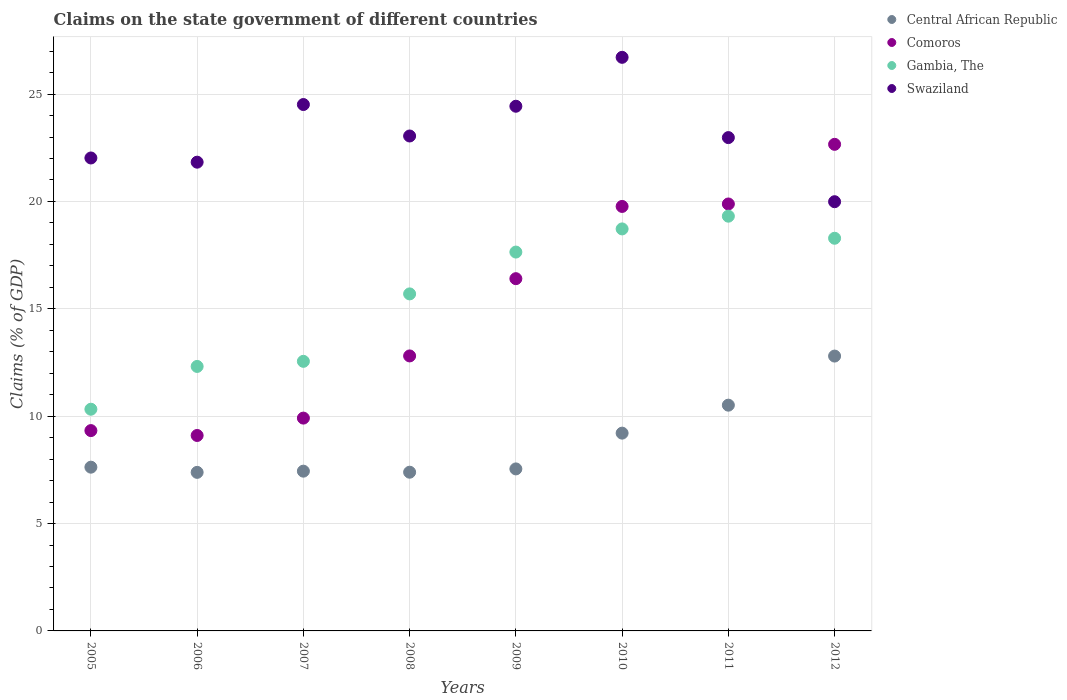How many different coloured dotlines are there?
Make the answer very short. 4. Is the number of dotlines equal to the number of legend labels?
Your answer should be very brief. Yes. What is the percentage of GDP claimed on the state government in Central African Republic in 2010?
Your answer should be compact. 9.21. Across all years, what is the maximum percentage of GDP claimed on the state government in Swaziland?
Keep it short and to the point. 26.71. Across all years, what is the minimum percentage of GDP claimed on the state government in Gambia, The?
Ensure brevity in your answer.  10.32. In which year was the percentage of GDP claimed on the state government in Comoros minimum?
Offer a terse response. 2006. What is the total percentage of GDP claimed on the state government in Central African Republic in the graph?
Offer a very short reply. 69.91. What is the difference between the percentage of GDP claimed on the state government in Comoros in 2005 and that in 2012?
Your answer should be very brief. -13.33. What is the difference between the percentage of GDP claimed on the state government in Swaziland in 2006 and the percentage of GDP claimed on the state government in Central African Republic in 2010?
Your answer should be very brief. 12.62. What is the average percentage of GDP claimed on the state government in Gambia, The per year?
Offer a terse response. 15.61. In the year 2006, what is the difference between the percentage of GDP claimed on the state government in Swaziland and percentage of GDP claimed on the state government in Comoros?
Keep it short and to the point. 12.73. In how many years, is the percentage of GDP claimed on the state government in Gambia, The greater than 8 %?
Make the answer very short. 8. What is the ratio of the percentage of GDP claimed on the state government in Comoros in 2006 to that in 2011?
Keep it short and to the point. 0.46. Is the percentage of GDP claimed on the state government in Comoros in 2010 less than that in 2012?
Offer a terse response. Yes. Is the difference between the percentage of GDP claimed on the state government in Swaziland in 2008 and 2010 greater than the difference between the percentage of GDP claimed on the state government in Comoros in 2008 and 2010?
Provide a succinct answer. Yes. What is the difference between the highest and the second highest percentage of GDP claimed on the state government in Gambia, The?
Offer a terse response. 0.59. What is the difference between the highest and the lowest percentage of GDP claimed on the state government in Gambia, The?
Give a very brief answer. 8.99. Is it the case that in every year, the sum of the percentage of GDP claimed on the state government in Central African Republic and percentage of GDP claimed on the state government in Gambia, The  is greater than the sum of percentage of GDP claimed on the state government in Comoros and percentage of GDP claimed on the state government in Swaziland?
Keep it short and to the point. No. Does the percentage of GDP claimed on the state government in Comoros monotonically increase over the years?
Ensure brevity in your answer.  No. How many dotlines are there?
Give a very brief answer. 4. How many years are there in the graph?
Your answer should be compact. 8. What is the difference between two consecutive major ticks on the Y-axis?
Ensure brevity in your answer.  5. Are the values on the major ticks of Y-axis written in scientific E-notation?
Provide a succinct answer. No. Does the graph contain any zero values?
Offer a terse response. No. What is the title of the graph?
Offer a very short reply. Claims on the state government of different countries. What is the label or title of the X-axis?
Ensure brevity in your answer.  Years. What is the label or title of the Y-axis?
Your answer should be very brief. Claims (% of GDP). What is the Claims (% of GDP) in Central African Republic in 2005?
Keep it short and to the point. 7.63. What is the Claims (% of GDP) of Comoros in 2005?
Make the answer very short. 9.33. What is the Claims (% of GDP) in Gambia, The in 2005?
Keep it short and to the point. 10.32. What is the Claims (% of GDP) of Swaziland in 2005?
Keep it short and to the point. 22.03. What is the Claims (% of GDP) in Central African Republic in 2006?
Provide a succinct answer. 7.38. What is the Claims (% of GDP) of Comoros in 2006?
Provide a succinct answer. 9.1. What is the Claims (% of GDP) in Gambia, The in 2006?
Give a very brief answer. 12.32. What is the Claims (% of GDP) in Swaziland in 2006?
Provide a short and direct response. 21.83. What is the Claims (% of GDP) of Central African Republic in 2007?
Your answer should be compact. 7.44. What is the Claims (% of GDP) in Comoros in 2007?
Ensure brevity in your answer.  9.91. What is the Claims (% of GDP) of Gambia, The in 2007?
Offer a very short reply. 12.55. What is the Claims (% of GDP) of Swaziland in 2007?
Make the answer very short. 24.51. What is the Claims (% of GDP) of Central African Republic in 2008?
Provide a succinct answer. 7.39. What is the Claims (% of GDP) of Comoros in 2008?
Your answer should be compact. 12.81. What is the Claims (% of GDP) of Gambia, The in 2008?
Make the answer very short. 15.7. What is the Claims (% of GDP) in Swaziland in 2008?
Keep it short and to the point. 23.05. What is the Claims (% of GDP) of Central African Republic in 2009?
Give a very brief answer. 7.54. What is the Claims (% of GDP) of Comoros in 2009?
Keep it short and to the point. 16.4. What is the Claims (% of GDP) in Gambia, The in 2009?
Provide a succinct answer. 17.64. What is the Claims (% of GDP) in Swaziland in 2009?
Your answer should be compact. 24.43. What is the Claims (% of GDP) of Central African Republic in 2010?
Your answer should be very brief. 9.21. What is the Claims (% of GDP) in Comoros in 2010?
Keep it short and to the point. 19.77. What is the Claims (% of GDP) in Gambia, The in 2010?
Provide a succinct answer. 18.72. What is the Claims (% of GDP) in Swaziland in 2010?
Make the answer very short. 26.71. What is the Claims (% of GDP) in Central African Republic in 2011?
Your response must be concise. 10.51. What is the Claims (% of GDP) of Comoros in 2011?
Your answer should be compact. 19.88. What is the Claims (% of GDP) of Gambia, The in 2011?
Offer a terse response. 19.31. What is the Claims (% of GDP) of Swaziland in 2011?
Your response must be concise. 22.97. What is the Claims (% of GDP) in Central African Republic in 2012?
Offer a terse response. 12.8. What is the Claims (% of GDP) of Comoros in 2012?
Ensure brevity in your answer.  22.66. What is the Claims (% of GDP) in Gambia, The in 2012?
Ensure brevity in your answer.  18.29. What is the Claims (% of GDP) of Swaziland in 2012?
Provide a succinct answer. 19.99. Across all years, what is the maximum Claims (% of GDP) of Central African Republic?
Make the answer very short. 12.8. Across all years, what is the maximum Claims (% of GDP) of Comoros?
Offer a very short reply. 22.66. Across all years, what is the maximum Claims (% of GDP) in Gambia, The?
Your response must be concise. 19.31. Across all years, what is the maximum Claims (% of GDP) in Swaziland?
Ensure brevity in your answer.  26.71. Across all years, what is the minimum Claims (% of GDP) of Central African Republic?
Your response must be concise. 7.38. Across all years, what is the minimum Claims (% of GDP) of Comoros?
Provide a short and direct response. 9.1. Across all years, what is the minimum Claims (% of GDP) in Gambia, The?
Offer a very short reply. 10.32. Across all years, what is the minimum Claims (% of GDP) in Swaziland?
Give a very brief answer. 19.99. What is the total Claims (% of GDP) of Central African Republic in the graph?
Provide a succinct answer. 69.91. What is the total Claims (% of GDP) in Comoros in the graph?
Keep it short and to the point. 119.86. What is the total Claims (% of GDP) of Gambia, The in the graph?
Provide a succinct answer. 124.86. What is the total Claims (% of GDP) of Swaziland in the graph?
Offer a terse response. 185.53. What is the difference between the Claims (% of GDP) in Central African Republic in 2005 and that in 2006?
Ensure brevity in your answer.  0.24. What is the difference between the Claims (% of GDP) of Comoros in 2005 and that in 2006?
Keep it short and to the point. 0.23. What is the difference between the Claims (% of GDP) in Gambia, The in 2005 and that in 2006?
Make the answer very short. -1.99. What is the difference between the Claims (% of GDP) of Swaziland in 2005 and that in 2006?
Give a very brief answer. 0.2. What is the difference between the Claims (% of GDP) in Central African Republic in 2005 and that in 2007?
Your answer should be very brief. 0.19. What is the difference between the Claims (% of GDP) of Comoros in 2005 and that in 2007?
Provide a succinct answer. -0.58. What is the difference between the Claims (% of GDP) in Gambia, The in 2005 and that in 2007?
Offer a terse response. -2.23. What is the difference between the Claims (% of GDP) in Swaziland in 2005 and that in 2007?
Offer a terse response. -2.49. What is the difference between the Claims (% of GDP) in Central African Republic in 2005 and that in 2008?
Offer a terse response. 0.23. What is the difference between the Claims (% of GDP) of Comoros in 2005 and that in 2008?
Offer a terse response. -3.48. What is the difference between the Claims (% of GDP) of Gambia, The in 2005 and that in 2008?
Ensure brevity in your answer.  -5.37. What is the difference between the Claims (% of GDP) in Swaziland in 2005 and that in 2008?
Offer a terse response. -1.02. What is the difference between the Claims (% of GDP) in Central African Republic in 2005 and that in 2009?
Your response must be concise. 0.08. What is the difference between the Claims (% of GDP) of Comoros in 2005 and that in 2009?
Give a very brief answer. -7.08. What is the difference between the Claims (% of GDP) of Gambia, The in 2005 and that in 2009?
Your answer should be compact. -7.32. What is the difference between the Claims (% of GDP) in Swaziland in 2005 and that in 2009?
Ensure brevity in your answer.  -2.41. What is the difference between the Claims (% of GDP) of Central African Republic in 2005 and that in 2010?
Offer a very short reply. -1.59. What is the difference between the Claims (% of GDP) of Comoros in 2005 and that in 2010?
Provide a short and direct response. -10.44. What is the difference between the Claims (% of GDP) of Gambia, The in 2005 and that in 2010?
Your response must be concise. -8.4. What is the difference between the Claims (% of GDP) in Swaziland in 2005 and that in 2010?
Offer a very short reply. -4.69. What is the difference between the Claims (% of GDP) of Central African Republic in 2005 and that in 2011?
Your answer should be compact. -2.89. What is the difference between the Claims (% of GDP) in Comoros in 2005 and that in 2011?
Offer a very short reply. -10.55. What is the difference between the Claims (% of GDP) in Gambia, The in 2005 and that in 2011?
Your response must be concise. -8.99. What is the difference between the Claims (% of GDP) in Swaziland in 2005 and that in 2011?
Give a very brief answer. -0.95. What is the difference between the Claims (% of GDP) in Central African Republic in 2005 and that in 2012?
Provide a succinct answer. -5.17. What is the difference between the Claims (% of GDP) of Comoros in 2005 and that in 2012?
Ensure brevity in your answer.  -13.33. What is the difference between the Claims (% of GDP) in Gambia, The in 2005 and that in 2012?
Make the answer very short. -7.96. What is the difference between the Claims (% of GDP) in Swaziland in 2005 and that in 2012?
Ensure brevity in your answer.  2.04. What is the difference between the Claims (% of GDP) in Central African Republic in 2006 and that in 2007?
Offer a very short reply. -0.06. What is the difference between the Claims (% of GDP) in Comoros in 2006 and that in 2007?
Keep it short and to the point. -0.81. What is the difference between the Claims (% of GDP) in Gambia, The in 2006 and that in 2007?
Provide a succinct answer. -0.24. What is the difference between the Claims (% of GDP) in Swaziland in 2006 and that in 2007?
Make the answer very short. -2.68. What is the difference between the Claims (% of GDP) in Central African Republic in 2006 and that in 2008?
Give a very brief answer. -0.01. What is the difference between the Claims (% of GDP) in Comoros in 2006 and that in 2008?
Make the answer very short. -3.7. What is the difference between the Claims (% of GDP) in Gambia, The in 2006 and that in 2008?
Give a very brief answer. -3.38. What is the difference between the Claims (% of GDP) of Swaziland in 2006 and that in 2008?
Offer a terse response. -1.22. What is the difference between the Claims (% of GDP) in Central African Republic in 2006 and that in 2009?
Provide a short and direct response. -0.16. What is the difference between the Claims (% of GDP) of Comoros in 2006 and that in 2009?
Provide a short and direct response. -7.3. What is the difference between the Claims (% of GDP) in Gambia, The in 2006 and that in 2009?
Your response must be concise. -5.33. What is the difference between the Claims (% of GDP) in Swaziland in 2006 and that in 2009?
Provide a short and direct response. -2.6. What is the difference between the Claims (% of GDP) in Central African Republic in 2006 and that in 2010?
Your response must be concise. -1.83. What is the difference between the Claims (% of GDP) in Comoros in 2006 and that in 2010?
Your answer should be compact. -10.67. What is the difference between the Claims (% of GDP) of Gambia, The in 2006 and that in 2010?
Offer a very short reply. -6.4. What is the difference between the Claims (% of GDP) of Swaziland in 2006 and that in 2010?
Make the answer very short. -4.88. What is the difference between the Claims (% of GDP) of Central African Republic in 2006 and that in 2011?
Offer a very short reply. -3.13. What is the difference between the Claims (% of GDP) in Comoros in 2006 and that in 2011?
Keep it short and to the point. -10.78. What is the difference between the Claims (% of GDP) in Gambia, The in 2006 and that in 2011?
Provide a succinct answer. -7. What is the difference between the Claims (% of GDP) in Swaziland in 2006 and that in 2011?
Your response must be concise. -1.14. What is the difference between the Claims (% of GDP) of Central African Republic in 2006 and that in 2012?
Keep it short and to the point. -5.42. What is the difference between the Claims (% of GDP) in Comoros in 2006 and that in 2012?
Provide a succinct answer. -13.56. What is the difference between the Claims (% of GDP) in Gambia, The in 2006 and that in 2012?
Provide a short and direct response. -5.97. What is the difference between the Claims (% of GDP) of Swaziland in 2006 and that in 2012?
Offer a very short reply. 1.84. What is the difference between the Claims (% of GDP) of Central African Republic in 2007 and that in 2008?
Provide a succinct answer. 0.05. What is the difference between the Claims (% of GDP) of Comoros in 2007 and that in 2008?
Your response must be concise. -2.9. What is the difference between the Claims (% of GDP) of Gambia, The in 2007 and that in 2008?
Keep it short and to the point. -3.14. What is the difference between the Claims (% of GDP) of Swaziland in 2007 and that in 2008?
Your response must be concise. 1.47. What is the difference between the Claims (% of GDP) of Central African Republic in 2007 and that in 2009?
Your answer should be compact. -0.11. What is the difference between the Claims (% of GDP) in Comoros in 2007 and that in 2009?
Provide a short and direct response. -6.49. What is the difference between the Claims (% of GDP) of Gambia, The in 2007 and that in 2009?
Offer a very short reply. -5.09. What is the difference between the Claims (% of GDP) of Swaziland in 2007 and that in 2009?
Provide a short and direct response. 0.08. What is the difference between the Claims (% of GDP) of Central African Republic in 2007 and that in 2010?
Keep it short and to the point. -1.77. What is the difference between the Claims (% of GDP) in Comoros in 2007 and that in 2010?
Keep it short and to the point. -9.86. What is the difference between the Claims (% of GDP) of Gambia, The in 2007 and that in 2010?
Offer a terse response. -6.17. What is the difference between the Claims (% of GDP) of Swaziland in 2007 and that in 2010?
Your answer should be very brief. -2.2. What is the difference between the Claims (% of GDP) of Central African Republic in 2007 and that in 2011?
Your answer should be compact. -3.07. What is the difference between the Claims (% of GDP) in Comoros in 2007 and that in 2011?
Give a very brief answer. -9.97. What is the difference between the Claims (% of GDP) of Gambia, The in 2007 and that in 2011?
Provide a short and direct response. -6.76. What is the difference between the Claims (% of GDP) in Swaziland in 2007 and that in 2011?
Give a very brief answer. 1.54. What is the difference between the Claims (% of GDP) of Central African Republic in 2007 and that in 2012?
Your answer should be compact. -5.36. What is the difference between the Claims (% of GDP) of Comoros in 2007 and that in 2012?
Provide a short and direct response. -12.75. What is the difference between the Claims (% of GDP) of Gambia, The in 2007 and that in 2012?
Keep it short and to the point. -5.73. What is the difference between the Claims (% of GDP) of Swaziland in 2007 and that in 2012?
Give a very brief answer. 4.53. What is the difference between the Claims (% of GDP) of Central African Republic in 2008 and that in 2009?
Your answer should be compact. -0.15. What is the difference between the Claims (% of GDP) in Comoros in 2008 and that in 2009?
Offer a terse response. -3.6. What is the difference between the Claims (% of GDP) of Gambia, The in 2008 and that in 2009?
Your response must be concise. -1.95. What is the difference between the Claims (% of GDP) of Swaziland in 2008 and that in 2009?
Your answer should be very brief. -1.39. What is the difference between the Claims (% of GDP) in Central African Republic in 2008 and that in 2010?
Offer a very short reply. -1.82. What is the difference between the Claims (% of GDP) in Comoros in 2008 and that in 2010?
Your answer should be very brief. -6.96. What is the difference between the Claims (% of GDP) of Gambia, The in 2008 and that in 2010?
Give a very brief answer. -3.03. What is the difference between the Claims (% of GDP) of Swaziland in 2008 and that in 2010?
Make the answer very short. -3.66. What is the difference between the Claims (% of GDP) in Central African Republic in 2008 and that in 2011?
Ensure brevity in your answer.  -3.12. What is the difference between the Claims (% of GDP) of Comoros in 2008 and that in 2011?
Your answer should be compact. -7.08. What is the difference between the Claims (% of GDP) of Gambia, The in 2008 and that in 2011?
Provide a short and direct response. -3.62. What is the difference between the Claims (% of GDP) of Swaziland in 2008 and that in 2011?
Make the answer very short. 0.07. What is the difference between the Claims (% of GDP) of Central African Republic in 2008 and that in 2012?
Your response must be concise. -5.41. What is the difference between the Claims (% of GDP) in Comoros in 2008 and that in 2012?
Give a very brief answer. -9.85. What is the difference between the Claims (% of GDP) in Gambia, The in 2008 and that in 2012?
Provide a short and direct response. -2.59. What is the difference between the Claims (% of GDP) of Swaziland in 2008 and that in 2012?
Your response must be concise. 3.06. What is the difference between the Claims (% of GDP) in Central African Republic in 2009 and that in 2010?
Your answer should be compact. -1.67. What is the difference between the Claims (% of GDP) of Comoros in 2009 and that in 2010?
Provide a short and direct response. -3.36. What is the difference between the Claims (% of GDP) of Gambia, The in 2009 and that in 2010?
Give a very brief answer. -1.08. What is the difference between the Claims (% of GDP) of Swaziland in 2009 and that in 2010?
Make the answer very short. -2.28. What is the difference between the Claims (% of GDP) of Central African Republic in 2009 and that in 2011?
Keep it short and to the point. -2.97. What is the difference between the Claims (% of GDP) in Comoros in 2009 and that in 2011?
Provide a succinct answer. -3.48. What is the difference between the Claims (% of GDP) of Gambia, The in 2009 and that in 2011?
Keep it short and to the point. -1.67. What is the difference between the Claims (% of GDP) in Swaziland in 2009 and that in 2011?
Your answer should be compact. 1.46. What is the difference between the Claims (% of GDP) in Central African Republic in 2009 and that in 2012?
Your response must be concise. -5.25. What is the difference between the Claims (% of GDP) in Comoros in 2009 and that in 2012?
Offer a very short reply. -6.26. What is the difference between the Claims (% of GDP) of Gambia, The in 2009 and that in 2012?
Keep it short and to the point. -0.64. What is the difference between the Claims (% of GDP) in Swaziland in 2009 and that in 2012?
Offer a very short reply. 4.45. What is the difference between the Claims (% of GDP) in Central African Republic in 2010 and that in 2011?
Give a very brief answer. -1.3. What is the difference between the Claims (% of GDP) in Comoros in 2010 and that in 2011?
Your answer should be very brief. -0.11. What is the difference between the Claims (% of GDP) in Gambia, The in 2010 and that in 2011?
Your answer should be very brief. -0.59. What is the difference between the Claims (% of GDP) in Swaziland in 2010 and that in 2011?
Ensure brevity in your answer.  3.74. What is the difference between the Claims (% of GDP) in Central African Republic in 2010 and that in 2012?
Offer a very short reply. -3.59. What is the difference between the Claims (% of GDP) in Comoros in 2010 and that in 2012?
Your response must be concise. -2.89. What is the difference between the Claims (% of GDP) in Gambia, The in 2010 and that in 2012?
Make the answer very short. 0.43. What is the difference between the Claims (% of GDP) of Swaziland in 2010 and that in 2012?
Ensure brevity in your answer.  6.72. What is the difference between the Claims (% of GDP) of Central African Republic in 2011 and that in 2012?
Offer a very short reply. -2.29. What is the difference between the Claims (% of GDP) in Comoros in 2011 and that in 2012?
Offer a very short reply. -2.78. What is the difference between the Claims (% of GDP) in Gambia, The in 2011 and that in 2012?
Your answer should be compact. 1.03. What is the difference between the Claims (% of GDP) in Swaziland in 2011 and that in 2012?
Offer a terse response. 2.99. What is the difference between the Claims (% of GDP) of Central African Republic in 2005 and the Claims (% of GDP) of Comoros in 2006?
Offer a very short reply. -1.48. What is the difference between the Claims (% of GDP) of Central African Republic in 2005 and the Claims (% of GDP) of Gambia, The in 2006?
Ensure brevity in your answer.  -4.69. What is the difference between the Claims (% of GDP) in Central African Republic in 2005 and the Claims (% of GDP) in Swaziland in 2006?
Your response must be concise. -14.2. What is the difference between the Claims (% of GDP) of Comoros in 2005 and the Claims (% of GDP) of Gambia, The in 2006?
Your answer should be compact. -2.99. What is the difference between the Claims (% of GDP) in Comoros in 2005 and the Claims (% of GDP) in Swaziland in 2006?
Give a very brief answer. -12.5. What is the difference between the Claims (% of GDP) of Gambia, The in 2005 and the Claims (% of GDP) of Swaziland in 2006?
Keep it short and to the point. -11.51. What is the difference between the Claims (% of GDP) in Central African Republic in 2005 and the Claims (% of GDP) in Comoros in 2007?
Make the answer very short. -2.29. What is the difference between the Claims (% of GDP) in Central African Republic in 2005 and the Claims (% of GDP) in Gambia, The in 2007?
Make the answer very short. -4.93. What is the difference between the Claims (% of GDP) in Central African Republic in 2005 and the Claims (% of GDP) in Swaziland in 2007?
Your response must be concise. -16.89. What is the difference between the Claims (% of GDP) of Comoros in 2005 and the Claims (% of GDP) of Gambia, The in 2007?
Ensure brevity in your answer.  -3.23. What is the difference between the Claims (% of GDP) of Comoros in 2005 and the Claims (% of GDP) of Swaziland in 2007?
Offer a very short reply. -15.18. What is the difference between the Claims (% of GDP) in Gambia, The in 2005 and the Claims (% of GDP) in Swaziland in 2007?
Ensure brevity in your answer.  -14.19. What is the difference between the Claims (% of GDP) of Central African Republic in 2005 and the Claims (% of GDP) of Comoros in 2008?
Offer a very short reply. -5.18. What is the difference between the Claims (% of GDP) in Central African Republic in 2005 and the Claims (% of GDP) in Gambia, The in 2008?
Provide a succinct answer. -8.07. What is the difference between the Claims (% of GDP) in Central African Republic in 2005 and the Claims (% of GDP) in Swaziland in 2008?
Your answer should be compact. -15.42. What is the difference between the Claims (% of GDP) of Comoros in 2005 and the Claims (% of GDP) of Gambia, The in 2008?
Your answer should be compact. -6.37. What is the difference between the Claims (% of GDP) of Comoros in 2005 and the Claims (% of GDP) of Swaziland in 2008?
Provide a short and direct response. -13.72. What is the difference between the Claims (% of GDP) of Gambia, The in 2005 and the Claims (% of GDP) of Swaziland in 2008?
Keep it short and to the point. -12.72. What is the difference between the Claims (% of GDP) of Central African Republic in 2005 and the Claims (% of GDP) of Comoros in 2009?
Your response must be concise. -8.78. What is the difference between the Claims (% of GDP) of Central African Republic in 2005 and the Claims (% of GDP) of Gambia, The in 2009?
Your response must be concise. -10.02. What is the difference between the Claims (% of GDP) in Central African Republic in 2005 and the Claims (% of GDP) in Swaziland in 2009?
Make the answer very short. -16.81. What is the difference between the Claims (% of GDP) of Comoros in 2005 and the Claims (% of GDP) of Gambia, The in 2009?
Your answer should be compact. -8.31. What is the difference between the Claims (% of GDP) of Comoros in 2005 and the Claims (% of GDP) of Swaziland in 2009?
Your response must be concise. -15.11. What is the difference between the Claims (% of GDP) of Gambia, The in 2005 and the Claims (% of GDP) of Swaziland in 2009?
Ensure brevity in your answer.  -14.11. What is the difference between the Claims (% of GDP) of Central African Republic in 2005 and the Claims (% of GDP) of Comoros in 2010?
Your response must be concise. -12.14. What is the difference between the Claims (% of GDP) of Central African Republic in 2005 and the Claims (% of GDP) of Gambia, The in 2010?
Make the answer very short. -11.1. What is the difference between the Claims (% of GDP) in Central African Republic in 2005 and the Claims (% of GDP) in Swaziland in 2010?
Offer a terse response. -19.09. What is the difference between the Claims (% of GDP) in Comoros in 2005 and the Claims (% of GDP) in Gambia, The in 2010?
Keep it short and to the point. -9.39. What is the difference between the Claims (% of GDP) of Comoros in 2005 and the Claims (% of GDP) of Swaziland in 2010?
Your response must be concise. -17.38. What is the difference between the Claims (% of GDP) in Gambia, The in 2005 and the Claims (% of GDP) in Swaziland in 2010?
Make the answer very short. -16.39. What is the difference between the Claims (% of GDP) in Central African Republic in 2005 and the Claims (% of GDP) in Comoros in 2011?
Keep it short and to the point. -12.26. What is the difference between the Claims (% of GDP) in Central African Republic in 2005 and the Claims (% of GDP) in Gambia, The in 2011?
Ensure brevity in your answer.  -11.69. What is the difference between the Claims (% of GDP) in Central African Republic in 2005 and the Claims (% of GDP) in Swaziland in 2011?
Keep it short and to the point. -15.35. What is the difference between the Claims (% of GDP) of Comoros in 2005 and the Claims (% of GDP) of Gambia, The in 2011?
Your response must be concise. -9.99. What is the difference between the Claims (% of GDP) of Comoros in 2005 and the Claims (% of GDP) of Swaziland in 2011?
Your answer should be compact. -13.64. What is the difference between the Claims (% of GDP) in Gambia, The in 2005 and the Claims (% of GDP) in Swaziland in 2011?
Ensure brevity in your answer.  -12.65. What is the difference between the Claims (% of GDP) in Central African Republic in 2005 and the Claims (% of GDP) in Comoros in 2012?
Your response must be concise. -15.03. What is the difference between the Claims (% of GDP) of Central African Republic in 2005 and the Claims (% of GDP) of Gambia, The in 2012?
Give a very brief answer. -10.66. What is the difference between the Claims (% of GDP) of Central African Republic in 2005 and the Claims (% of GDP) of Swaziland in 2012?
Your response must be concise. -12.36. What is the difference between the Claims (% of GDP) in Comoros in 2005 and the Claims (% of GDP) in Gambia, The in 2012?
Provide a short and direct response. -8.96. What is the difference between the Claims (% of GDP) in Comoros in 2005 and the Claims (% of GDP) in Swaziland in 2012?
Provide a succinct answer. -10.66. What is the difference between the Claims (% of GDP) in Gambia, The in 2005 and the Claims (% of GDP) in Swaziland in 2012?
Give a very brief answer. -9.66. What is the difference between the Claims (% of GDP) in Central African Republic in 2006 and the Claims (% of GDP) in Comoros in 2007?
Offer a terse response. -2.53. What is the difference between the Claims (% of GDP) of Central African Republic in 2006 and the Claims (% of GDP) of Gambia, The in 2007?
Provide a succinct answer. -5.17. What is the difference between the Claims (% of GDP) of Central African Republic in 2006 and the Claims (% of GDP) of Swaziland in 2007?
Give a very brief answer. -17.13. What is the difference between the Claims (% of GDP) of Comoros in 2006 and the Claims (% of GDP) of Gambia, The in 2007?
Your response must be concise. -3.45. What is the difference between the Claims (% of GDP) in Comoros in 2006 and the Claims (% of GDP) in Swaziland in 2007?
Provide a short and direct response. -15.41. What is the difference between the Claims (% of GDP) in Gambia, The in 2006 and the Claims (% of GDP) in Swaziland in 2007?
Give a very brief answer. -12.2. What is the difference between the Claims (% of GDP) of Central African Republic in 2006 and the Claims (% of GDP) of Comoros in 2008?
Give a very brief answer. -5.42. What is the difference between the Claims (% of GDP) in Central African Republic in 2006 and the Claims (% of GDP) in Gambia, The in 2008?
Your response must be concise. -8.31. What is the difference between the Claims (% of GDP) in Central African Republic in 2006 and the Claims (% of GDP) in Swaziland in 2008?
Provide a succinct answer. -15.66. What is the difference between the Claims (% of GDP) in Comoros in 2006 and the Claims (% of GDP) in Gambia, The in 2008?
Your response must be concise. -6.59. What is the difference between the Claims (% of GDP) in Comoros in 2006 and the Claims (% of GDP) in Swaziland in 2008?
Make the answer very short. -13.95. What is the difference between the Claims (% of GDP) in Gambia, The in 2006 and the Claims (% of GDP) in Swaziland in 2008?
Provide a short and direct response. -10.73. What is the difference between the Claims (% of GDP) of Central African Republic in 2006 and the Claims (% of GDP) of Comoros in 2009?
Your answer should be very brief. -9.02. What is the difference between the Claims (% of GDP) of Central African Republic in 2006 and the Claims (% of GDP) of Gambia, The in 2009?
Offer a very short reply. -10.26. What is the difference between the Claims (% of GDP) of Central African Republic in 2006 and the Claims (% of GDP) of Swaziland in 2009?
Ensure brevity in your answer.  -17.05. What is the difference between the Claims (% of GDP) of Comoros in 2006 and the Claims (% of GDP) of Gambia, The in 2009?
Your answer should be compact. -8.54. What is the difference between the Claims (% of GDP) of Comoros in 2006 and the Claims (% of GDP) of Swaziland in 2009?
Provide a short and direct response. -15.33. What is the difference between the Claims (% of GDP) in Gambia, The in 2006 and the Claims (% of GDP) in Swaziland in 2009?
Keep it short and to the point. -12.12. What is the difference between the Claims (% of GDP) in Central African Republic in 2006 and the Claims (% of GDP) in Comoros in 2010?
Provide a succinct answer. -12.38. What is the difference between the Claims (% of GDP) in Central African Republic in 2006 and the Claims (% of GDP) in Gambia, The in 2010?
Offer a very short reply. -11.34. What is the difference between the Claims (% of GDP) of Central African Republic in 2006 and the Claims (% of GDP) of Swaziland in 2010?
Keep it short and to the point. -19.33. What is the difference between the Claims (% of GDP) of Comoros in 2006 and the Claims (% of GDP) of Gambia, The in 2010?
Keep it short and to the point. -9.62. What is the difference between the Claims (% of GDP) of Comoros in 2006 and the Claims (% of GDP) of Swaziland in 2010?
Provide a short and direct response. -17.61. What is the difference between the Claims (% of GDP) of Gambia, The in 2006 and the Claims (% of GDP) of Swaziland in 2010?
Give a very brief answer. -14.39. What is the difference between the Claims (% of GDP) of Central African Republic in 2006 and the Claims (% of GDP) of Comoros in 2011?
Provide a succinct answer. -12.5. What is the difference between the Claims (% of GDP) of Central African Republic in 2006 and the Claims (% of GDP) of Gambia, The in 2011?
Offer a very short reply. -11.93. What is the difference between the Claims (% of GDP) of Central African Republic in 2006 and the Claims (% of GDP) of Swaziland in 2011?
Ensure brevity in your answer.  -15.59. What is the difference between the Claims (% of GDP) of Comoros in 2006 and the Claims (% of GDP) of Gambia, The in 2011?
Offer a very short reply. -10.21. What is the difference between the Claims (% of GDP) in Comoros in 2006 and the Claims (% of GDP) in Swaziland in 2011?
Provide a succinct answer. -13.87. What is the difference between the Claims (% of GDP) in Gambia, The in 2006 and the Claims (% of GDP) in Swaziland in 2011?
Your answer should be compact. -10.66. What is the difference between the Claims (% of GDP) of Central African Republic in 2006 and the Claims (% of GDP) of Comoros in 2012?
Provide a short and direct response. -15.28. What is the difference between the Claims (% of GDP) in Central African Republic in 2006 and the Claims (% of GDP) in Gambia, The in 2012?
Make the answer very short. -10.9. What is the difference between the Claims (% of GDP) of Central African Republic in 2006 and the Claims (% of GDP) of Swaziland in 2012?
Ensure brevity in your answer.  -12.6. What is the difference between the Claims (% of GDP) of Comoros in 2006 and the Claims (% of GDP) of Gambia, The in 2012?
Your response must be concise. -9.18. What is the difference between the Claims (% of GDP) of Comoros in 2006 and the Claims (% of GDP) of Swaziland in 2012?
Keep it short and to the point. -10.89. What is the difference between the Claims (% of GDP) of Gambia, The in 2006 and the Claims (% of GDP) of Swaziland in 2012?
Keep it short and to the point. -7.67. What is the difference between the Claims (% of GDP) in Central African Republic in 2007 and the Claims (% of GDP) in Comoros in 2008?
Offer a terse response. -5.37. What is the difference between the Claims (% of GDP) of Central African Republic in 2007 and the Claims (% of GDP) of Gambia, The in 2008?
Give a very brief answer. -8.26. What is the difference between the Claims (% of GDP) in Central African Republic in 2007 and the Claims (% of GDP) in Swaziland in 2008?
Keep it short and to the point. -15.61. What is the difference between the Claims (% of GDP) of Comoros in 2007 and the Claims (% of GDP) of Gambia, The in 2008?
Provide a succinct answer. -5.78. What is the difference between the Claims (% of GDP) in Comoros in 2007 and the Claims (% of GDP) in Swaziland in 2008?
Offer a terse response. -13.14. What is the difference between the Claims (% of GDP) of Gambia, The in 2007 and the Claims (% of GDP) of Swaziland in 2008?
Ensure brevity in your answer.  -10.49. What is the difference between the Claims (% of GDP) of Central African Republic in 2007 and the Claims (% of GDP) of Comoros in 2009?
Your response must be concise. -8.96. What is the difference between the Claims (% of GDP) in Central African Republic in 2007 and the Claims (% of GDP) in Gambia, The in 2009?
Ensure brevity in your answer.  -10.2. What is the difference between the Claims (% of GDP) of Central African Republic in 2007 and the Claims (% of GDP) of Swaziland in 2009?
Provide a short and direct response. -16.99. What is the difference between the Claims (% of GDP) of Comoros in 2007 and the Claims (% of GDP) of Gambia, The in 2009?
Ensure brevity in your answer.  -7.73. What is the difference between the Claims (% of GDP) of Comoros in 2007 and the Claims (% of GDP) of Swaziland in 2009?
Keep it short and to the point. -14.52. What is the difference between the Claims (% of GDP) in Gambia, The in 2007 and the Claims (% of GDP) in Swaziland in 2009?
Provide a short and direct response. -11.88. What is the difference between the Claims (% of GDP) of Central African Republic in 2007 and the Claims (% of GDP) of Comoros in 2010?
Keep it short and to the point. -12.33. What is the difference between the Claims (% of GDP) in Central African Republic in 2007 and the Claims (% of GDP) in Gambia, The in 2010?
Offer a terse response. -11.28. What is the difference between the Claims (% of GDP) of Central African Republic in 2007 and the Claims (% of GDP) of Swaziland in 2010?
Your response must be concise. -19.27. What is the difference between the Claims (% of GDP) in Comoros in 2007 and the Claims (% of GDP) in Gambia, The in 2010?
Provide a short and direct response. -8.81. What is the difference between the Claims (% of GDP) in Comoros in 2007 and the Claims (% of GDP) in Swaziland in 2010?
Ensure brevity in your answer.  -16.8. What is the difference between the Claims (% of GDP) of Gambia, The in 2007 and the Claims (% of GDP) of Swaziland in 2010?
Give a very brief answer. -14.16. What is the difference between the Claims (% of GDP) of Central African Republic in 2007 and the Claims (% of GDP) of Comoros in 2011?
Your answer should be compact. -12.44. What is the difference between the Claims (% of GDP) of Central African Republic in 2007 and the Claims (% of GDP) of Gambia, The in 2011?
Your answer should be very brief. -11.87. What is the difference between the Claims (% of GDP) in Central African Republic in 2007 and the Claims (% of GDP) in Swaziland in 2011?
Provide a short and direct response. -15.53. What is the difference between the Claims (% of GDP) in Comoros in 2007 and the Claims (% of GDP) in Gambia, The in 2011?
Your answer should be compact. -9.4. What is the difference between the Claims (% of GDP) in Comoros in 2007 and the Claims (% of GDP) in Swaziland in 2011?
Your answer should be compact. -13.06. What is the difference between the Claims (% of GDP) in Gambia, The in 2007 and the Claims (% of GDP) in Swaziland in 2011?
Give a very brief answer. -10.42. What is the difference between the Claims (% of GDP) of Central African Republic in 2007 and the Claims (% of GDP) of Comoros in 2012?
Ensure brevity in your answer.  -15.22. What is the difference between the Claims (% of GDP) of Central African Republic in 2007 and the Claims (% of GDP) of Gambia, The in 2012?
Give a very brief answer. -10.85. What is the difference between the Claims (% of GDP) in Central African Republic in 2007 and the Claims (% of GDP) in Swaziland in 2012?
Offer a terse response. -12.55. What is the difference between the Claims (% of GDP) in Comoros in 2007 and the Claims (% of GDP) in Gambia, The in 2012?
Offer a terse response. -8.38. What is the difference between the Claims (% of GDP) in Comoros in 2007 and the Claims (% of GDP) in Swaziland in 2012?
Give a very brief answer. -10.08. What is the difference between the Claims (% of GDP) of Gambia, The in 2007 and the Claims (% of GDP) of Swaziland in 2012?
Your response must be concise. -7.43. What is the difference between the Claims (% of GDP) of Central African Republic in 2008 and the Claims (% of GDP) of Comoros in 2009?
Your answer should be compact. -9.01. What is the difference between the Claims (% of GDP) in Central African Republic in 2008 and the Claims (% of GDP) in Gambia, The in 2009?
Offer a terse response. -10.25. What is the difference between the Claims (% of GDP) in Central African Republic in 2008 and the Claims (% of GDP) in Swaziland in 2009?
Make the answer very short. -17.04. What is the difference between the Claims (% of GDP) in Comoros in 2008 and the Claims (% of GDP) in Gambia, The in 2009?
Offer a terse response. -4.84. What is the difference between the Claims (% of GDP) of Comoros in 2008 and the Claims (% of GDP) of Swaziland in 2009?
Your answer should be compact. -11.63. What is the difference between the Claims (% of GDP) of Gambia, The in 2008 and the Claims (% of GDP) of Swaziland in 2009?
Make the answer very short. -8.74. What is the difference between the Claims (% of GDP) in Central African Republic in 2008 and the Claims (% of GDP) in Comoros in 2010?
Keep it short and to the point. -12.38. What is the difference between the Claims (% of GDP) of Central African Republic in 2008 and the Claims (% of GDP) of Gambia, The in 2010?
Your response must be concise. -11.33. What is the difference between the Claims (% of GDP) of Central African Republic in 2008 and the Claims (% of GDP) of Swaziland in 2010?
Provide a succinct answer. -19.32. What is the difference between the Claims (% of GDP) of Comoros in 2008 and the Claims (% of GDP) of Gambia, The in 2010?
Offer a terse response. -5.92. What is the difference between the Claims (% of GDP) of Comoros in 2008 and the Claims (% of GDP) of Swaziland in 2010?
Your response must be concise. -13.91. What is the difference between the Claims (% of GDP) of Gambia, The in 2008 and the Claims (% of GDP) of Swaziland in 2010?
Your response must be concise. -11.02. What is the difference between the Claims (% of GDP) in Central African Republic in 2008 and the Claims (% of GDP) in Comoros in 2011?
Offer a very short reply. -12.49. What is the difference between the Claims (% of GDP) in Central African Republic in 2008 and the Claims (% of GDP) in Gambia, The in 2011?
Offer a terse response. -11.92. What is the difference between the Claims (% of GDP) in Central African Republic in 2008 and the Claims (% of GDP) in Swaziland in 2011?
Offer a terse response. -15.58. What is the difference between the Claims (% of GDP) of Comoros in 2008 and the Claims (% of GDP) of Gambia, The in 2011?
Offer a terse response. -6.51. What is the difference between the Claims (% of GDP) of Comoros in 2008 and the Claims (% of GDP) of Swaziland in 2011?
Make the answer very short. -10.17. What is the difference between the Claims (% of GDP) in Gambia, The in 2008 and the Claims (% of GDP) in Swaziland in 2011?
Your response must be concise. -7.28. What is the difference between the Claims (% of GDP) in Central African Republic in 2008 and the Claims (% of GDP) in Comoros in 2012?
Make the answer very short. -15.27. What is the difference between the Claims (% of GDP) of Central African Republic in 2008 and the Claims (% of GDP) of Gambia, The in 2012?
Provide a succinct answer. -10.9. What is the difference between the Claims (% of GDP) in Central African Republic in 2008 and the Claims (% of GDP) in Swaziland in 2012?
Your answer should be very brief. -12.6. What is the difference between the Claims (% of GDP) in Comoros in 2008 and the Claims (% of GDP) in Gambia, The in 2012?
Keep it short and to the point. -5.48. What is the difference between the Claims (% of GDP) of Comoros in 2008 and the Claims (% of GDP) of Swaziland in 2012?
Ensure brevity in your answer.  -7.18. What is the difference between the Claims (% of GDP) of Gambia, The in 2008 and the Claims (% of GDP) of Swaziland in 2012?
Your answer should be very brief. -4.29. What is the difference between the Claims (% of GDP) in Central African Republic in 2009 and the Claims (% of GDP) in Comoros in 2010?
Offer a terse response. -12.22. What is the difference between the Claims (% of GDP) of Central African Republic in 2009 and the Claims (% of GDP) of Gambia, The in 2010?
Your answer should be compact. -11.18. What is the difference between the Claims (% of GDP) of Central African Republic in 2009 and the Claims (% of GDP) of Swaziland in 2010?
Offer a terse response. -19.17. What is the difference between the Claims (% of GDP) of Comoros in 2009 and the Claims (% of GDP) of Gambia, The in 2010?
Keep it short and to the point. -2.32. What is the difference between the Claims (% of GDP) in Comoros in 2009 and the Claims (% of GDP) in Swaziland in 2010?
Your response must be concise. -10.31. What is the difference between the Claims (% of GDP) of Gambia, The in 2009 and the Claims (% of GDP) of Swaziland in 2010?
Provide a short and direct response. -9.07. What is the difference between the Claims (% of GDP) in Central African Republic in 2009 and the Claims (% of GDP) in Comoros in 2011?
Provide a succinct answer. -12.34. What is the difference between the Claims (% of GDP) of Central African Republic in 2009 and the Claims (% of GDP) of Gambia, The in 2011?
Keep it short and to the point. -11.77. What is the difference between the Claims (% of GDP) of Central African Republic in 2009 and the Claims (% of GDP) of Swaziland in 2011?
Offer a very short reply. -15.43. What is the difference between the Claims (% of GDP) of Comoros in 2009 and the Claims (% of GDP) of Gambia, The in 2011?
Your response must be concise. -2.91. What is the difference between the Claims (% of GDP) of Comoros in 2009 and the Claims (% of GDP) of Swaziland in 2011?
Ensure brevity in your answer.  -6.57. What is the difference between the Claims (% of GDP) of Gambia, The in 2009 and the Claims (% of GDP) of Swaziland in 2011?
Provide a succinct answer. -5.33. What is the difference between the Claims (% of GDP) of Central African Republic in 2009 and the Claims (% of GDP) of Comoros in 2012?
Offer a very short reply. -15.12. What is the difference between the Claims (% of GDP) in Central African Republic in 2009 and the Claims (% of GDP) in Gambia, The in 2012?
Your answer should be very brief. -10.74. What is the difference between the Claims (% of GDP) of Central African Republic in 2009 and the Claims (% of GDP) of Swaziland in 2012?
Give a very brief answer. -12.44. What is the difference between the Claims (% of GDP) in Comoros in 2009 and the Claims (% of GDP) in Gambia, The in 2012?
Ensure brevity in your answer.  -1.88. What is the difference between the Claims (% of GDP) of Comoros in 2009 and the Claims (% of GDP) of Swaziland in 2012?
Offer a very short reply. -3.58. What is the difference between the Claims (% of GDP) of Gambia, The in 2009 and the Claims (% of GDP) of Swaziland in 2012?
Provide a short and direct response. -2.35. What is the difference between the Claims (% of GDP) of Central African Republic in 2010 and the Claims (% of GDP) of Comoros in 2011?
Give a very brief answer. -10.67. What is the difference between the Claims (% of GDP) of Central African Republic in 2010 and the Claims (% of GDP) of Gambia, The in 2011?
Keep it short and to the point. -10.1. What is the difference between the Claims (% of GDP) in Central African Republic in 2010 and the Claims (% of GDP) in Swaziland in 2011?
Offer a very short reply. -13.76. What is the difference between the Claims (% of GDP) in Comoros in 2010 and the Claims (% of GDP) in Gambia, The in 2011?
Your answer should be very brief. 0.45. What is the difference between the Claims (% of GDP) in Comoros in 2010 and the Claims (% of GDP) in Swaziland in 2011?
Offer a terse response. -3.21. What is the difference between the Claims (% of GDP) of Gambia, The in 2010 and the Claims (% of GDP) of Swaziland in 2011?
Your answer should be compact. -4.25. What is the difference between the Claims (% of GDP) in Central African Republic in 2010 and the Claims (% of GDP) in Comoros in 2012?
Offer a very short reply. -13.45. What is the difference between the Claims (% of GDP) in Central African Republic in 2010 and the Claims (% of GDP) in Gambia, The in 2012?
Keep it short and to the point. -9.08. What is the difference between the Claims (% of GDP) of Central African Republic in 2010 and the Claims (% of GDP) of Swaziland in 2012?
Offer a terse response. -10.78. What is the difference between the Claims (% of GDP) in Comoros in 2010 and the Claims (% of GDP) in Gambia, The in 2012?
Keep it short and to the point. 1.48. What is the difference between the Claims (% of GDP) in Comoros in 2010 and the Claims (% of GDP) in Swaziland in 2012?
Offer a very short reply. -0.22. What is the difference between the Claims (% of GDP) of Gambia, The in 2010 and the Claims (% of GDP) of Swaziland in 2012?
Your answer should be compact. -1.27. What is the difference between the Claims (% of GDP) of Central African Republic in 2011 and the Claims (% of GDP) of Comoros in 2012?
Make the answer very short. -12.15. What is the difference between the Claims (% of GDP) of Central African Republic in 2011 and the Claims (% of GDP) of Gambia, The in 2012?
Your answer should be very brief. -7.77. What is the difference between the Claims (% of GDP) in Central African Republic in 2011 and the Claims (% of GDP) in Swaziland in 2012?
Ensure brevity in your answer.  -9.47. What is the difference between the Claims (% of GDP) of Comoros in 2011 and the Claims (% of GDP) of Gambia, The in 2012?
Provide a succinct answer. 1.6. What is the difference between the Claims (% of GDP) of Comoros in 2011 and the Claims (% of GDP) of Swaziland in 2012?
Your response must be concise. -0.11. What is the difference between the Claims (% of GDP) of Gambia, The in 2011 and the Claims (% of GDP) of Swaziland in 2012?
Offer a terse response. -0.67. What is the average Claims (% of GDP) of Central African Republic per year?
Offer a very short reply. 8.74. What is the average Claims (% of GDP) in Comoros per year?
Your response must be concise. 14.98. What is the average Claims (% of GDP) in Gambia, The per year?
Ensure brevity in your answer.  15.61. What is the average Claims (% of GDP) in Swaziland per year?
Your answer should be compact. 23.19. In the year 2005, what is the difference between the Claims (% of GDP) in Central African Republic and Claims (% of GDP) in Comoros?
Make the answer very short. -1.7. In the year 2005, what is the difference between the Claims (% of GDP) of Central African Republic and Claims (% of GDP) of Gambia, The?
Your answer should be compact. -2.7. In the year 2005, what is the difference between the Claims (% of GDP) in Central African Republic and Claims (% of GDP) in Swaziland?
Keep it short and to the point. -14.4. In the year 2005, what is the difference between the Claims (% of GDP) in Comoros and Claims (% of GDP) in Gambia, The?
Your answer should be very brief. -1. In the year 2005, what is the difference between the Claims (% of GDP) in Comoros and Claims (% of GDP) in Swaziland?
Your answer should be very brief. -12.7. In the year 2005, what is the difference between the Claims (% of GDP) in Gambia, The and Claims (% of GDP) in Swaziland?
Offer a very short reply. -11.7. In the year 2006, what is the difference between the Claims (% of GDP) of Central African Republic and Claims (% of GDP) of Comoros?
Give a very brief answer. -1.72. In the year 2006, what is the difference between the Claims (% of GDP) of Central African Republic and Claims (% of GDP) of Gambia, The?
Offer a very short reply. -4.93. In the year 2006, what is the difference between the Claims (% of GDP) in Central African Republic and Claims (% of GDP) in Swaziland?
Your response must be concise. -14.45. In the year 2006, what is the difference between the Claims (% of GDP) in Comoros and Claims (% of GDP) in Gambia, The?
Your answer should be very brief. -3.22. In the year 2006, what is the difference between the Claims (% of GDP) of Comoros and Claims (% of GDP) of Swaziland?
Your response must be concise. -12.73. In the year 2006, what is the difference between the Claims (% of GDP) of Gambia, The and Claims (% of GDP) of Swaziland?
Give a very brief answer. -9.51. In the year 2007, what is the difference between the Claims (% of GDP) of Central African Republic and Claims (% of GDP) of Comoros?
Keep it short and to the point. -2.47. In the year 2007, what is the difference between the Claims (% of GDP) of Central African Republic and Claims (% of GDP) of Gambia, The?
Your answer should be compact. -5.11. In the year 2007, what is the difference between the Claims (% of GDP) in Central African Republic and Claims (% of GDP) in Swaziland?
Offer a terse response. -17.07. In the year 2007, what is the difference between the Claims (% of GDP) of Comoros and Claims (% of GDP) of Gambia, The?
Your answer should be compact. -2.64. In the year 2007, what is the difference between the Claims (% of GDP) in Comoros and Claims (% of GDP) in Swaziland?
Your response must be concise. -14.6. In the year 2007, what is the difference between the Claims (% of GDP) in Gambia, The and Claims (% of GDP) in Swaziland?
Your answer should be very brief. -11.96. In the year 2008, what is the difference between the Claims (% of GDP) of Central African Republic and Claims (% of GDP) of Comoros?
Make the answer very short. -5.41. In the year 2008, what is the difference between the Claims (% of GDP) in Central African Republic and Claims (% of GDP) in Gambia, The?
Ensure brevity in your answer.  -8.3. In the year 2008, what is the difference between the Claims (% of GDP) in Central African Republic and Claims (% of GDP) in Swaziland?
Your response must be concise. -15.66. In the year 2008, what is the difference between the Claims (% of GDP) in Comoros and Claims (% of GDP) in Gambia, The?
Give a very brief answer. -2.89. In the year 2008, what is the difference between the Claims (% of GDP) in Comoros and Claims (% of GDP) in Swaziland?
Keep it short and to the point. -10.24. In the year 2008, what is the difference between the Claims (% of GDP) of Gambia, The and Claims (% of GDP) of Swaziland?
Offer a very short reply. -7.35. In the year 2009, what is the difference between the Claims (% of GDP) of Central African Republic and Claims (% of GDP) of Comoros?
Keep it short and to the point. -8.86. In the year 2009, what is the difference between the Claims (% of GDP) of Central African Republic and Claims (% of GDP) of Gambia, The?
Your answer should be very brief. -10.1. In the year 2009, what is the difference between the Claims (% of GDP) of Central African Republic and Claims (% of GDP) of Swaziland?
Your answer should be very brief. -16.89. In the year 2009, what is the difference between the Claims (% of GDP) of Comoros and Claims (% of GDP) of Gambia, The?
Provide a short and direct response. -1.24. In the year 2009, what is the difference between the Claims (% of GDP) of Comoros and Claims (% of GDP) of Swaziland?
Ensure brevity in your answer.  -8.03. In the year 2009, what is the difference between the Claims (% of GDP) in Gambia, The and Claims (% of GDP) in Swaziland?
Your response must be concise. -6.79. In the year 2010, what is the difference between the Claims (% of GDP) in Central African Republic and Claims (% of GDP) in Comoros?
Offer a terse response. -10.56. In the year 2010, what is the difference between the Claims (% of GDP) of Central African Republic and Claims (% of GDP) of Gambia, The?
Ensure brevity in your answer.  -9.51. In the year 2010, what is the difference between the Claims (% of GDP) in Central African Republic and Claims (% of GDP) in Swaziland?
Your answer should be compact. -17.5. In the year 2010, what is the difference between the Claims (% of GDP) of Comoros and Claims (% of GDP) of Gambia, The?
Your response must be concise. 1.05. In the year 2010, what is the difference between the Claims (% of GDP) of Comoros and Claims (% of GDP) of Swaziland?
Give a very brief answer. -6.94. In the year 2010, what is the difference between the Claims (% of GDP) in Gambia, The and Claims (% of GDP) in Swaziland?
Offer a very short reply. -7.99. In the year 2011, what is the difference between the Claims (% of GDP) of Central African Republic and Claims (% of GDP) of Comoros?
Your response must be concise. -9.37. In the year 2011, what is the difference between the Claims (% of GDP) in Central African Republic and Claims (% of GDP) in Gambia, The?
Offer a terse response. -8.8. In the year 2011, what is the difference between the Claims (% of GDP) in Central African Republic and Claims (% of GDP) in Swaziland?
Offer a very short reply. -12.46. In the year 2011, what is the difference between the Claims (% of GDP) of Comoros and Claims (% of GDP) of Gambia, The?
Provide a succinct answer. 0.57. In the year 2011, what is the difference between the Claims (% of GDP) of Comoros and Claims (% of GDP) of Swaziland?
Ensure brevity in your answer.  -3.09. In the year 2011, what is the difference between the Claims (% of GDP) of Gambia, The and Claims (% of GDP) of Swaziland?
Give a very brief answer. -3.66. In the year 2012, what is the difference between the Claims (% of GDP) of Central African Republic and Claims (% of GDP) of Comoros?
Offer a terse response. -9.86. In the year 2012, what is the difference between the Claims (% of GDP) in Central African Republic and Claims (% of GDP) in Gambia, The?
Your response must be concise. -5.49. In the year 2012, what is the difference between the Claims (% of GDP) in Central African Republic and Claims (% of GDP) in Swaziland?
Your answer should be very brief. -7.19. In the year 2012, what is the difference between the Claims (% of GDP) of Comoros and Claims (% of GDP) of Gambia, The?
Give a very brief answer. 4.37. In the year 2012, what is the difference between the Claims (% of GDP) of Comoros and Claims (% of GDP) of Swaziland?
Offer a very short reply. 2.67. In the year 2012, what is the difference between the Claims (% of GDP) in Gambia, The and Claims (% of GDP) in Swaziland?
Make the answer very short. -1.7. What is the ratio of the Claims (% of GDP) of Central African Republic in 2005 to that in 2006?
Your answer should be very brief. 1.03. What is the ratio of the Claims (% of GDP) of Gambia, The in 2005 to that in 2006?
Your response must be concise. 0.84. What is the ratio of the Claims (% of GDP) in Swaziland in 2005 to that in 2006?
Provide a succinct answer. 1.01. What is the ratio of the Claims (% of GDP) in Central African Republic in 2005 to that in 2007?
Make the answer very short. 1.02. What is the ratio of the Claims (% of GDP) in Comoros in 2005 to that in 2007?
Your answer should be very brief. 0.94. What is the ratio of the Claims (% of GDP) of Gambia, The in 2005 to that in 2007?
Offer a very short reply. 0.82. What is the ratio of the Claims (% of GDP) in Swaziland in 2005 to that in 2007?
Your response must be concise. 0.9. What is the ratio of the Claims (% of GDP) of Central African Republic in 2005 to that in 2008?
Your response must be concise. 1.03. What is the ratio of the Claims (% of GDP) in Comoros in 2005 to that in 2008?
Ensure brevity in your answer.  0.73. What is the ratio of the Claims (% of GDP) of Gambia, The in 2005 to that in 2008?
Provide a short and direct response. 0.66. What is the ratio of the Claims (% of GDP) in Swaziland in 2005 to that in 2008?
Provide a succinct answer. 0.96. What is the ratio of the Claims (% of GDP) of Central African Republic in 2005 to that in 2009?
Keep it short and to the point. 1.01. What is the ratio of the Claims (% of GDP) of Comoros in 2005 to that in 2009?
Provide a short and direct response. 0.57. What is the ratio of the Claims (% of GDP) of Gambia, The in 2005 to that in 2009?
Offer a terse response. 0.59. What is the ratio of the Claims (% of GDP) in Swaziland in 2005 to that in 2009?
Make the answer very short. 0.9. What is the ratio of the Claims (% of GDP) in Central African Republic in 2005 to that in 2010?
Make the answer very short. 0.83. What is the ratio of the Claims (% of GDP) of Comoros in 2005 to that in 2010?
Your response must be concise. 0.47. What is the ratio of the Claims (% of GDP) in Gambia, The in 2005 to that in 2010?
Make the answer very short. 0.55. What is the ratio of the Claims (% of GDP) in Swaziland in 2005 to that in 2010?
Make the answer very short. 0.82. What is the ratio of the Claims (% of GDP) of Central African Republic in 2005 to that in 2011?
Your answer should be compact. 0.73. What is the ratio of the Claims (% of GDP) in Comoros in 2005 to that in 2011?
Provide a succinct answer. 0.47. What is the ratio of the Claims (% of GDP) in Gambia, The in 2005 to that in 2011?
Make the answer very short. 0.53. What is the ratio of the Claims (% of GDP) of Swaziland in 2005 to that in 2011?
Provide a short and direct response. 0.96. What is the ratio of the Claims (% of GDP) of Central African Republic in 2005 to that in 2012?
Provide a short and direct response. 0.6. What is the ratio of the Claims (% of GDP) of Comoros in 2005 to that in 2012?
Keep it short and to the point. 0.41. What is the ratio of the Claims (% of GDP) of Gambia, The in 2005 to that in 2012?
Provide a short and direct response. 0.56. What is the ratio of the Claims (% of GDP) of Swaziland in 2005 to that in 2012?
Give a very brief answer. 1.1. What is the ratio of the Claims (% of GDP) in Comoros in 2006 to that in 2007?
Provide a short and direct response. 0.92. What is the ratio of the Claims (% of GDP) of Gambia, The in 2006 to that in 2007?
Offer a terse response. 0.98. What is the ratio of the Claims (% of GDP) of Swaziland in 2006 to that in 2007?
Provide a short and direct response. 0.89. What is the ratio of the Claims (% of GDP) in Central African Republic in 2006 to that in 2008?
Your answer should be compact. 1. What is the ratio of the Claims (% of GDP) in Comoros in 2006 to that in 2008?
Make the answer very short. 0.71. What is the ratio of the Claims (% of GDP) of Gambia, The in 2006 to that in 2008?
Make the answer very short. 0.78. What is the ratio of the Claims (% of GDP) in Swaziland in 2006 to that in 2008?
Provide a short and direct response. 0.95. What is the ratio of the Claims (% of GDP) in Central African Republic in 2006 to that in 2009?
Ensure brevity in your answer.  0.98. What is the ratio of the Claims (% of GDP) of Comoros in 2006 to that in 2009?
Ensure brevity in your answer.  0.55. What is the ratio of the Claims (% of GDP) of Gambia, The in 2006 to that in 2009?
Provide a short and direct response. 0.7. What is the ratio of the Claims (% of GDP) of Swaziland in 2006 to that in 2009?
Your answer should be very brief. 0.89. What is the ratio of the Claims (% of GDP) in Central African Republic in 2006 to that in 2010?
Provide a short and direct response. 0.8. What is the ratio of the Claims (% of GDP) in Comoros in 2006 to that in 2010?
Make the answer very short. 0.46. What is the ratio of the Claims (% of GDP) of Gambia, The in 2006 to that in 2010?
Keep it short and to the point. 0.66. What is the ratio of the Claims (% of GDP) in Swaziland in 2006 to that in 2010?
Offer a very short reply. 0.82. What is the ratio of the Claims (% of GDP) of Central African Republic in 2006 to that in 2011?
Offer a very short reply. 0.7. What is the ratio of the Claims (% of GDP) of Comoros in 2006 to that in 2011?
Keep it short and to the point. 0.46. What is the ratio of the Claims (% of GDP) of Gambia, The in 2006 to that in 2011?
Your response must be concise. 0.64. What is the ratio of the Claims (% of GDP) in Swaziland in 2006 to that in 2011?
Your answer should be compact. 0.95. What is the ratio of the Claims (% of GDP) of Central African Republic in 2006 to that in 2012?
Your response must be concise. 0.58. What is the ratio of the Claims (% of GDP) of Comoros in 2006 to that in 2012?
Provide a succinct answer. 0.4. What is the ratio of the Claims (% of GDP) in Gambia, The in 2006 to that in 2012?
Make the answer very short. 0.67. What is the ratio of the Claims (% of GDP) of Swaziland in 2006 to that in 2012?
Your answer should be very brief. 1.09. What is the ratio of the Claims (% of GDP) in Central African Republic in 2007 to that in 2008?
Keep it short and to the point. 1.01. What is the ratio of the Claims (% of GDP) in Comoros in 2007 to that in 2008?
Give a very brief answer. 0.77. What is the ratio of the Claims (% of GDP) of Gambia, The in 2007 to that in 2008?
Your response must be concise. 0.8. What is the ratio of the Claims (% of GDP) in Swaziland in 2007 to that in 2008?
Make the answer very short. 1.06. What is the ratio of the Claims (% of GDP) of Central African Republic in 2007 to that in 2009?
Provide a succinct answer. 0.99. What is the ratio of the Claims (% of GDP) of Comoros in 2007 to that in 2009?
Offer a very short reply. 0.6. What is the ratio of the Claims (% of GDP) in Gambia, The in 2007 to that in 2009?
Keep it short and to the point. 0.71. What is the ratio of the Claims (% of GDP) of Central African Republic in 2007 to that in 2010?
Your answer should be compact. 0.81. What is the ratio of the Claims (% of GDP) in Comoros in 2007 to that in 2010?
Make the answer very short. 0.5. What is the ratio of the Claims (% of GDP) of Gambia, The in 2007 to that in 2010?
Keep it short and to the point. 0.67. What is the ratio of the Claims (% of GDP) of Swaziland in 2007 to that in 2010?
Ensure brevity in your answer.  0.92. What is the ratio of the Claims (% of GDP) in Central African Republic in 2007 to that in 2011?
Give a very brief answer. 0.71. What is the ratio of the Claims (% of GDP) in Comoros in 2007 to that in 2011?
Keep it short and to the point. 0.5. What is the ratio of the Claims (% of GDP) of Gambia, The in 2007 to that in 2011?
Your answer should be very brief. 0.65. What is the ratio of the Claims (% of GDP) of Swaziland in 2007 to that in 2011?
Keep it short and to the point. 1.07. What is the ratio of the Claims (% of GDP) in Central African Republic in 2007 to that in 2012?
Offer a very short reply. 0.58. What is the ratio of the Claims (% of GDP) in Comoros in 2007 to that in 2012?
Offer a terse response. 0.44. What is the ratio of the Claims (% of GDP) of Gambia, The in 2007 to that in 2012?
Ensure brevity in your answer.  0.69. What is the ratio of the Claims (% of GDP) of Swaziland in 2007 to that in 2012?
Provide a succinct answer. 1.23. What is the ratio of the Claims (% of GDP) of Central African Republic in 2008 to that in 2009?
Your response must be concise. 0.98. What is the ratio of the Claims (% of GDP) in Comoros in 2008 to that in 2009?
Offer a terse response. 0.78. What is the ratio of the Claims (% of GDP) of Gambia, The in 2008 to that in 2009?
Your answer should be very brief. 0.89. What is the ratio of the Claims (% of GDP) of Swaziland in 2008 to that in 2009?
Your answer should be compact. 0.94. What is the ratio of the Claims (% of GDP) of Central African Republic in 2008 to that in 2010?
Your response must be concise. 0.8. What is the ratio of the Claims (% of GDP) in Comoros in 2008 to that in 2010?
Provide a short and direct response. 0.65. What is the ratio of the Claims (% of GDP) of Gambia, The in 2008 to that in 2010?
Ensure brevity in your answer.  0.84. What is the ratio of the Claims (% of GDP) of Swaziland in 2008 to that in 2010?
Make the answer very short. 0.86. What is the ratio of the Claims (% of GDP) in Central African Republic in 2008 to that in 2011?
Make the answer very short. 0.7. What is the ratio of the Claims (% of GDP) of Comoros in 2008 to that in 2011?
Make the answer very short. 0.64. What is the ratio of the Claims (% of GDP) in Gambia, The in 2008 to that in 2011?
Provide a short and direct response. 0.81. What is the ratio of the Claims (% of GDP) in Central African Republic in 2008 to that in 2012?
Your answer should be compact. 0.58. What is the ratio of the Claims (% of GDP) in Comoros in 2008 to that in 2012?
Keep it short and to the point. 0.57. What is the ratio of the Claims (% of GDP) in Gambia, The in 2008 to that in 2012?
Provide a succinct answer. 0.86. What is the ratio of the Claims (% of GDP) in Swaziland in 2008 to that in 2012?
Your answer should be very brief. 1.15. What is the ratio of the Claims (% of GDP) of Central African Republic in 2009 to that in 2010?
Make the answer very short. 0.82. What is the ratio of the Claims (% of GDP) in Comoros in 2009 to that in 2010?
Your answer should be very brief. 0.83. What is the ratio of the Claims (% of GDP) of Gambia, The in 2009 to that in 2010?
Make the answer very short. 0.94. What is the ratio of the Claims (% of GDP) of Swaziland in 2009 to that in 2010?
Offer a very short reply. 0.91. What is the ratio of the Claims (% of GDP) in Central African Republic in 2009 to that in 2011?
Provide a short and direct response. 0.72. What is the ratio of the Claims (% of GDP) of Comoros in 2009 to that in 2011?
Make the answer very short. 0.82. What is the ratio of the Claims (% of GDP) in Gambia, The in 2009 to that in 2011?
Keep it short and to the point. 0.91. What is the ratio of the Claims (% of GDP) of Swaziland in 2009 to that in 2011?
Your answer should be very brief. 1.06. What is the ratio of the Claims (% of GDP) of Central African Republic in 2009 to that in 2012?
Provide a succinct answer. 0.59. What is the ratio of the Claims (% of GDP) of Comoros in 2009 to that in 2012?
Your response must be concise. 0.72. What is the ratio of the Claims (% of GDP) of Gambia, The in 2009 to that in 2012?
Give a very brief answer. 0.96. What is the ratio of the Claims (% of GDP) in Swaziland in 2009 to that in 2012?
Your answer should be compact. 1.22. What is the ratio of the Claims (% of GDP) in Central African Republic in 2010 to that in 2011?
Provide a short and direct response. 0.88. What is the ratio of the Claims (% of GDP) of Comoros in 2010 to that in 2011?
Give a very brief answer. 0.99. What is the ratio of the Claims (% of GDP) in Gambia, The in 2010 to that in 2011?
Ensure brevity in your answer.  0.97. What is the ratio of the Claims (% of GDP) in Swaziland in 2010 to that in 2011?
Your answer should be very brief. 1.16. What is the ratio of the Claims (% of GDP) in Central African Republic in 2010 to that in 2012?
Your answer should be compact. 0.72. What is the ratio of the Claims (% of GDP) of Comoros in 2010 to that in 2012?
Provide a short and direct response. 0.87. What is the ratio of the Claims (% of GDP) of Gambia, The in 2010 to that in 2012?
Your answer should be compact. 1.02. What is the ratio of the Claims (% of GDP) in Swaziland in 2010 to that in 2012?
Give a very brief answer. 1.34. What is the ratio of the Claims (% of GDP) of Central African Republic in 2011 to that in 2012?
Offer a very short reply. 0.82. What is the ratio of the Claims (% of GDP) in Comoros in 2011 to that in 2012?
Provide a short and direct response. 0.88. What is the ratio of the Claims (% of GDP) in Gambia, The in 2011 to that in 2012?
Offer a terse response. 1.06. What is the ratio of the Claims (% of GDP) of Swaziland in 2011 to that in 2012?
Provide a succinct answer. 1.15. What is the difference between the highest and the second highest Claims (% of GDP) in Central African Republic?
Offer a very short reply. 2.29. What is the difference between the highest and the second highest Claims (% of GDP) of Comoros?
Offer a terse response. 2.78. What is the difference between the highest and the second highest Claims (% of GDP) of Gambia, The?
Give a very brief answer. 0.59. What is the difference between the highest and the second highest Claims (% of GDP) of Swaziland?
Your answer should be very brief. 2.2. What is the difference between the highest and the lowest Claims (% of GDP) in Central African Republic?
Ensure brevity in your answer.  5.42. What is the difference between the highest and the lowest Claims (% of GDP) in Comoros?
Offer a terse response. 13.56. What is the difference between the highest and the lowest Claims (% of GDP) in Gambia, The?
Give a very brief answer. 8.99. What is the difference between the highest and the lowest Claims (% of GDP) of Swaziland?
Provide a short and direct response. 6.72. 